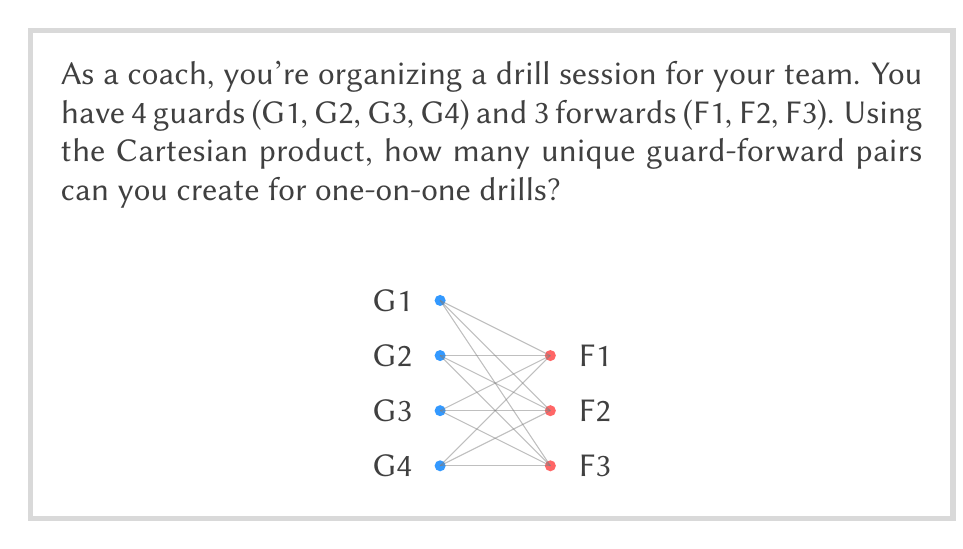Can you solve this math problem? Let's approach this step-by-step using set theory and the Cartesian product:

1) First, let's define our sets:
   Guards = $G = \{G1, G2, G3, G4\}$
   Forwards = $F = \{F1, F2, F3\}$

2) The Cartesian product of these sets, $G \times F$, will give us all possible guard-forward pairs.

3) The Cartesian product is defined as:
   $G \times F = \{(g,f) | g \in G \text{ and } f \in F\}$

4) To calculate the number of elements in the Cartesian product, we use the multiplication principle:
   $|G \times F| = |G| \cdot |F|$

5) We have:
   $|G| = 4$ (number of guards)
   $|F| = 3$ (number of forwards)

6) Therefore:
   $|G \times F| = 4 \cdot 3 = 12$

This means there are 12 unique guard-forward pairs possible.

To visualize this, imagine each of the 4 guards being paired with each of the 3 forwards, resulting in 12 different combinations.
Answer: 12 unique pairs 